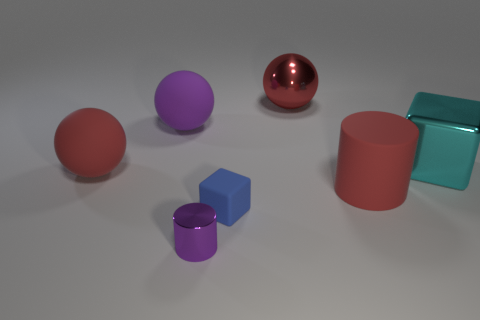Add 2 large objects. How many objects exist? 9 Subtract all spheres. How many objects are left? 4 Subtract all purple matte objects. Subtract all big red spheres. How many objects are left? 4 Add 5 purple things. How many purple things are left? 7 Add 2 big green metallic blocks. How many big green metallic blocks exist? 2 Subtract 1 red cylinders. How many objects are left? 6 